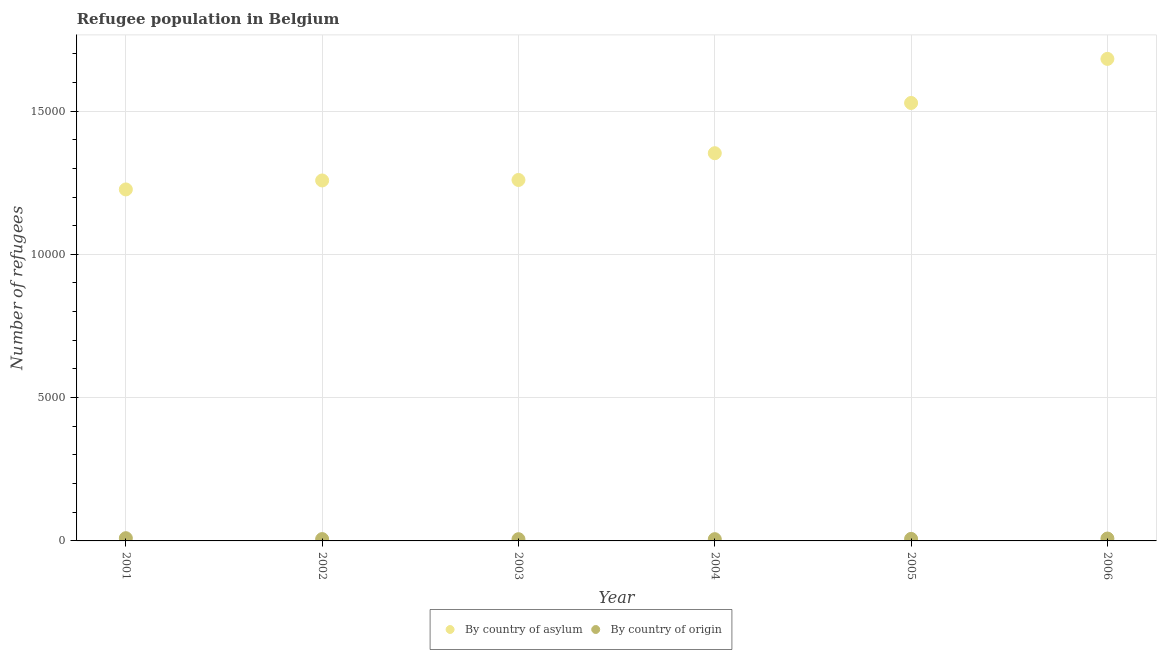What is the number of refugees by country of origin in 2002?
Your response must be concise. 64. Across all years, what is the maximum number of refugees by country of asylum?
Your answer should be very brief. 1.68e+04. Across all years, what is the minimum number of refugees by country of origin?
Keep it short and to the point. 60. What is the total number of refugees by country of asylum in the graph?
Your answer should be compact. 8.31e+04. What is the difference between the number of refugees by country of asylum in 2002 and that in 2003?
Provide a succinct answer. -17. What is the difference between the number of refugees by country of origin in 2004 and the number of refugees by country of asylum in 2005?
Provide a short and direct response. -1.52e+04. What is the average number of refugees by country of asylum per year?
Keep it short and to the point. 1.38e+04. In the year 2003, what is the difference between the number of refugees by country of asylum and number of refugees by country of origin?
Your response must be concise. 1.25e+04. What is the ratio of the number of refugees by country of asylum in 2001 to that in 2002?
Your answer should be compact. 0.98. Is the difference between the number of refugees by country of asylum in 2001 and 2002 greater than the difference between the number of refugees by country of origin in 2001 and 2002?
Your response must be concise. No. What is the difference between the highest and the second highest number of refugees by country of asylum?
Your response must be concise. 1538. What is the difference between the highest and the lowest number of refugees by country of origin?
Your answer should be very brief. 35. Is the sum of the number of refugees by country of asylum in 2003 and 2004 greater than the maximum number of refugees by country of origin across all years?
Provide a succinct answer. Yes. Is the number of refugees by country of origin strictly greater than the number of refugees by country of asylum over the years?
Ensure brevity in your answer.  No. How many years are there in the graph?
Offer a terse response. 6. What is the difference between two consecutive major ticks on the Y-axis?
Keep it short and to the point. 5000. Where does the legend appear in the graph?
Provide a short and direct response. Bottom center. How are the legend labels stacked?
Offer a very short reply. Horizontal. What is the title of the graph?
Your response must be concise. Refugee population in Belgium. Does "Working capital" appear as one of the legend labels in the graph?
Provide a short and direct response. No. What is the label or title of the X-axis?
Offer a terse response. Year. What is the label or title of the Y-axis?
Your answer should be compact. Number of refugees. What is the Number of refugees of By country of asylum in 2001?
Ensure brevity in your answer.  1.23e+04. What is the Number of refugees of By country of origin in 2001?
Your answer should be very brief. 95. What is the Number of refugees in By country of asylum in 2002?
Your response must be concise. 1.26e+04. What is the Number of refugees of By country of origin in 2002?
Keep it short and to the point. 64. What is the Number of refugees in By country of asylum in 2003?
Your answer should be compact. 1.26e+04. What is the Number of refugees in By country of asylum in 2004?
Your answer should be compact. 1.35e+04. What is the Number of refugees in By country of asylum in 2005?
Offer a very short reply. 1.53e+04. What is the Number of refugees of By country of origin in 2005?
Your answer should be very brief. 71. What is the Number of refugees of By country of asylum in 2006?
Provide a short and direct response. 1.68e+04. Across all years, what is the maximum Number of refugees in By country of asylum?
Offer a terse response. 1.68e+04. Across all years, what is the minimum Number of refugees of By country of asylum?
Provide a short and direct response. 1.23e+04. What is the total Number of refugees in By country of asylum in the graph?
Ensure brevity in your answer.  8.31e+04. What is the total Number of refugees of By country of origin in the graph?
Give a very brief answer. 434. What is the difference between the Number of refugees of By country of asylum in 2001 and that in 2002?
Provide a short and direct response. -313. What is the difference between the Number of refugees of By country of origin in 2001 and that in 2002?
Keep it short and to the point. 31. What is the difference between the Number of refugees of By country of asylum in 2001 and that in 2003?
Make the answer very short. -330. What is the difference between the Number of refugees in By country of origin in 2001 and that in 2003?
Your answer should be compact. 35. What is the difference between the Number of refugees of By country of asylum in 2001 and that in 2004?
Keep it short and to the point. -1264. What is the difference between the Number of refugees of By country of asylum in 2001 and that in 2005?
Offer a terse response. -3017. What is the difference between the Number of refugees in By country of asylum in 2001 and that in 2006?
Provide a succinct answer. -4555. What is the difference between the Number of refugees of By country of asylum in 2002 and that in 2004?
Provide a succinct answer. -951. What is the difference between the Number of refugees of By country of origin in 2002 and that in 2004?
Ensure brevity in your answer.  3. What is the difference between the Number of refugees of By country of asylum in 2002 and that in 2005?
Offer a terse response. -2704. What is the difference between the Number of refugees of By country of asylum in 2002 and that in 2006?
Ensure brevity in your answer.  -4242. What is the difference between the Number of refugees of By country of asylum in 2003 and that in 2004?
Offer a very short reply. -934. What is the difference between the Number of refugees of By country of asylum in 2003 and that in 2005?
Ensure brevity in your answer.  -2687. What is the difference between the Number of refugees of By country of origin in 2003 and that in 2005?
Make the answer very short. -11. What is the difference between the Number of refugees in By country of asylum in 2003 and that in 2006?
Make the answer very short. -4225. What is the difference between the Number of refugees in By country of asylum in 2004 and that in 2005?
Your answer should be very brief. -1753. What is the difference between the Number of refugees in By country of origin in 2004 and that in 2005?
Provide a succinct answer. -10. What is the difference between the Number of refugees in By country of asylum in 2004 and that in 2006?
Offer a terse response. -3291. What is the difference between the Number of refugees in By country of asylum in 2005 and that in 2006?
Provide a succinct answer. -1538. What is the difference between the Number of refugees of By country of asylum in 2001 and the Number of refugees of By country of origin in 2002?
Make the answer very short. 1.22e+04. What is the difference between the Number of refugees in By country of asylum in 2001 and the Number of refugees in By country of origin in 2003?
Give a very brief answer. 1.22e+04. What is the difference between the Number of refugees in By country of asylum in 2001 and the Number of refugees in By country of origin in 2004?
Provide a short and direct response. 1.22e+04. What is the difference between the Number of refugees of By country of asylum in 2001 and the Number of refugees of By country of origin in 2005?
Give a very brief answer. 1.22e+04. What is the difference between the Number of refugees in By country of asylum in 2001 and the Number of refugees in By country of origin in 2006?
Make the answer very short. 1.22e+04. What is the difference between the Number of refugees in By country of asylum in 2002 and the Number of refugees in By country of origin in 2003?
Keep it short and to the point. 1.25e+04. What is the difference between the Number of refugees in By country of asylum in 2002 and the Number of refugees in By country of origin in 2004?
Make the answer very short. 1.25e+04. What is the difference between the Number of refugees in By country of asylum in 2002 and the Number of refugees in By country of origin in 2005?
Give a very brief answer. 1.25e+04. What is the difference between the Number of refugees in By country of asylum in 2002 and the Number of refugees in By country of origin in 2006?
Make the answer very short. 1.25e+04. What is the difference between the Number of refugees in By country of asylum in 2003 and the Number of refugees in By country of origin in 2004?
Offer a very short reply. 1.25e+04. What is the difference between the Number of refugees of By country of asylum in 2003 and the Number of refugees of By country of origin in 2005?
Provide a short and direct response. 1.25e+04. What is the difference between the Number of refugees in By country of asylum in 2003 and the Number of refugees in By country of origin in 2006?
Keep it short and to the point. 1.25e+04. What is the difference between the Number of refugees of By country of asylum in 2004 and the Number of refugees of By country of origin in 2005?
Offer a terse response. 1.35e+04. What is the difference between the Number of refugees of By country of asylum in 2004 and the Number of refugees of By country of origin in 2006?
Ensure brevity in your answer.  1.34e+04. What is the difference between the Number of refugees in By country of asylum in 2005 and the Number of refugees in By country of origin in 2006?
Provide a succinct answer. 1.52e+04. What is the average Number of refugees of By country of asylum per year?
Your answer should be compact. 1.38e+04. What is the average Number of refugees in By country of origin per year?
Your answer should be very brief. 72.33. In the year 2001, what is the difference between the Number of refugees of By country of asylum and Number of refugees of By country of origin?
Give a very brief answer. 1.22e+04. In the year 2002, what is the difference between the Number of refugees in By country of asylum and Number of refugees in By country of origin?
Provide a succinct answer. 1.25e+04. In the year 2003, what is the difference between the Number of refugees of By country of asylum and Number of refugees of By country of origin?
Give a very brief answer. 1.25e+04. In the year 2004, what is the difference between the Number of refugees in By country of asylum and Number of refugees in By country of origin?
Make the answer very short. 1.35e+04. In the year 2005, what is the difference between the Number of refugees of By country of asylum and Number of refugees of By country of origin?
Provide a succinct answer. 1.52e+04. In the year 2006, what is the difference between the Number of refugees of By country of asylum and Number of refugees of By country of origin?
Provide a short and direct response. 1.67e+04. What is the ratio of the Number of refugees of By country of asylum in 2001 to that in 2002?
Make the answer very short. 0.98. What is the ratio of the Number of refugees in By country of origin in 2001 to that in 2002?
Offer a very short reply. 1.48. What is the ratio of the Number of refugees of By country of asylum in 2001 to that in 2003?
Provide a short and direct response. 0.97. What is the ratio of the Number of refugees in By country of origin in 2001 to that in 2003?
Your answer should be very brief. 1.58. What is the ratio of the Number of refugees of By country of asylum in 2001 to that in 2004?
Provide a short and direct response. 0.91. What is the ratio of the Number of refugees in By country of origin in 2001 to that in 2004?
Provide a short and direct response. 1.56. What is the ratio of the Number of refugees in By country of asylum in 2001 to that in 2005?
Your answer should be compact. 0.8. What is the ratio of the Number of refugees of By country of origin in 2001 to that in 2005?
Make the answer very short. 1.34. What is the ratio of the Number of refugees in By country of asylum in 2001 to that in 2006?
Your answer should be compact. 0.73. What is the ratio of the Number of refugees of By country of origin in 2001 to that in 2006?
Keep it short and to the point. 1.14. What is the ratio of the Number of refugees in By country of origin in 2002 to that in 2003?
Your answer should be compact. 1.07. What is the ratio of the Number of refugees in By country of asylum in 2002 to that in 2004?
Your answer should be compact. 0.93. What is the ratio of the Number of refugees of By country of origin in 2002 to that in 2004?
Make the answer very short. 1.05. What is the ratio of the Number of refugees of By country of asylum in 2002 to that in 2005?
Your answer should be compact. 0.82. What is the ratio of the Number of refugees of By country of origin in 2002 to that in 2005?
Your answer should be compact. 0.9. What is the ratio of the Number of refugees of By country of asylum in 2002 to that in 2006?
Offer a terse response. 0.75. What is the ratio of the Number of refugees of By country of origin in 2002 to that in 2006?
Your answer should be compact. 0.77. What is the ratio of the Number of refugees of By country of origin in 2003 to that in 2004?
Provide a short and direct response. 0.98. What is the ratio of the Number of refugees of By country of asylum in 2003 to that in 2005?
Make the answer very short. 0.82. What is the ratio of the Number of refugees of By country of origin in 2003 to that in 2005?
Provide a succinct answer. 0.85. What is the ratio of the Number of refugees in By country of asylum in 2003 to that in 2006?
Your answer should be very brief. 0.75. What is the ratio of the Number of refugees in By country of origin in 2003 to that in 2006?
Your response must be concise. 0.72. What is the ratio of the Number of refugees in By country of asylum in 2004 to that in 2005?
Offer a terse response. 0.89. What is the ratio of the Number of refugees of By country of origin in 2004 to that in 2005?
Ensure brevity in your answer.  0.86. What is the ratio of the Number of refugees of By country of asylum in 2004 to that in 2006?
Ensure brevity in your answer.  0.8. What is the ratio of the Number of refugees in By country of origin in 2004 to that in 2006?
Provide a succinct answer. 0.73. What is the ratio of the Number of refugees in By country of asylum in 2005 to that in 2006?
Your answer should be compact. 0.91. What is the ratio of the Number of refugees of By country of origin in 2005 to that in 2006?
Offer a very short reply. 0.86. What is the difference between the highest and the second highest Number of refugees in By country of asylum?
Give a very brief answer. 1538. What is the difference between the highest and the lowest Number of refugees of By country of asylum?
Give a very brief answer. 4555. 